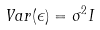<formula> <loc_0><loc_0><loc_500><loc_500>V a r ( \epsilon ) = \sigma ^ { 2 } I</formula> 